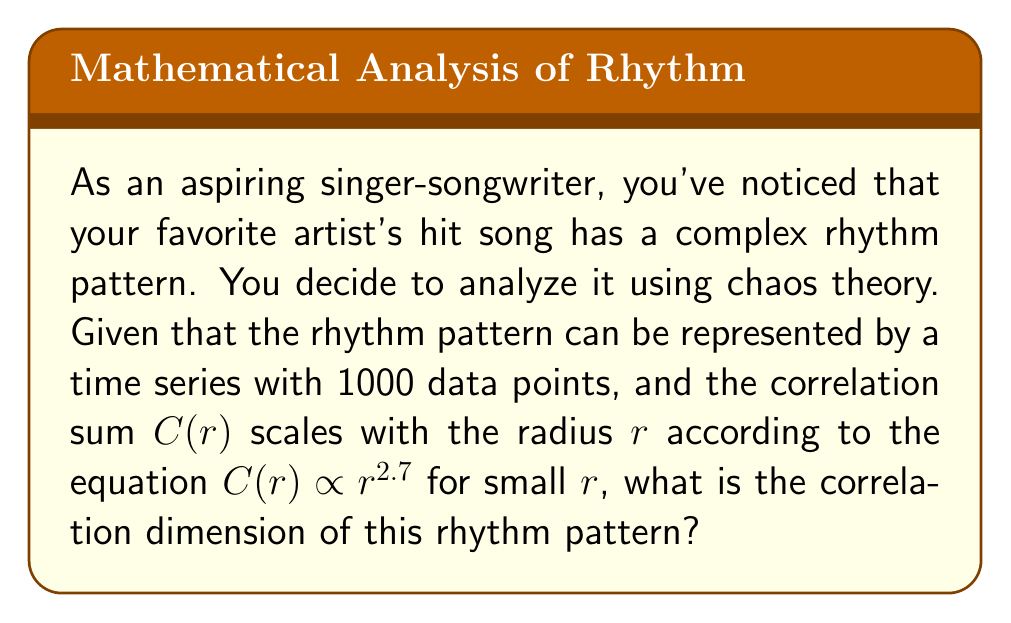Can you solve this math problem? To determine the correlation dimension of the complex rhythm pattern, we'll follow these steps:

1. Recall that the correlation dimension $D_2$ is defined by the scaling relation:

   $$C(r) \propto r^{D_2}$$

   where $C(r)$ is the correlation sum and $r$ is the radius.

2. In this case, we're given that:

   $$C(r) \propto r^{2.7}$$

3. Comparing the given equation with the definition, we can see that the exponent 2.7 directly corresponds to the correlation dimension $D_2$.

4. Therefore, the correlation dimension of the rhythm pattern is 2.7.

This fractional dimension suggests that the rhythm pattern has a fractal-like structure, indicating a high level of complexity and potentially chaotic behavior. As an aspiring singer-songwriter, understanding this complexity could inspire you to create more intricate and engaging rhythms in your own compositions.
Answer: $D_2 = 2.7$ 